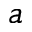Convert formula to latex. <formula><loc_0><loc_0><loc_500><loc_500>^ { a }</formula> 